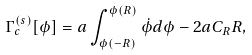<formula> <loc_0><loc_0><loc_500><loc_500>\Gamma ^ { ( s ) } _ { c } [ \phi ] = a \int ^ { \phi ( R ) } _ { \phi ( - R ) } \dot { \phi } d \phi - 2 a C _ { R } R ,</formula> 